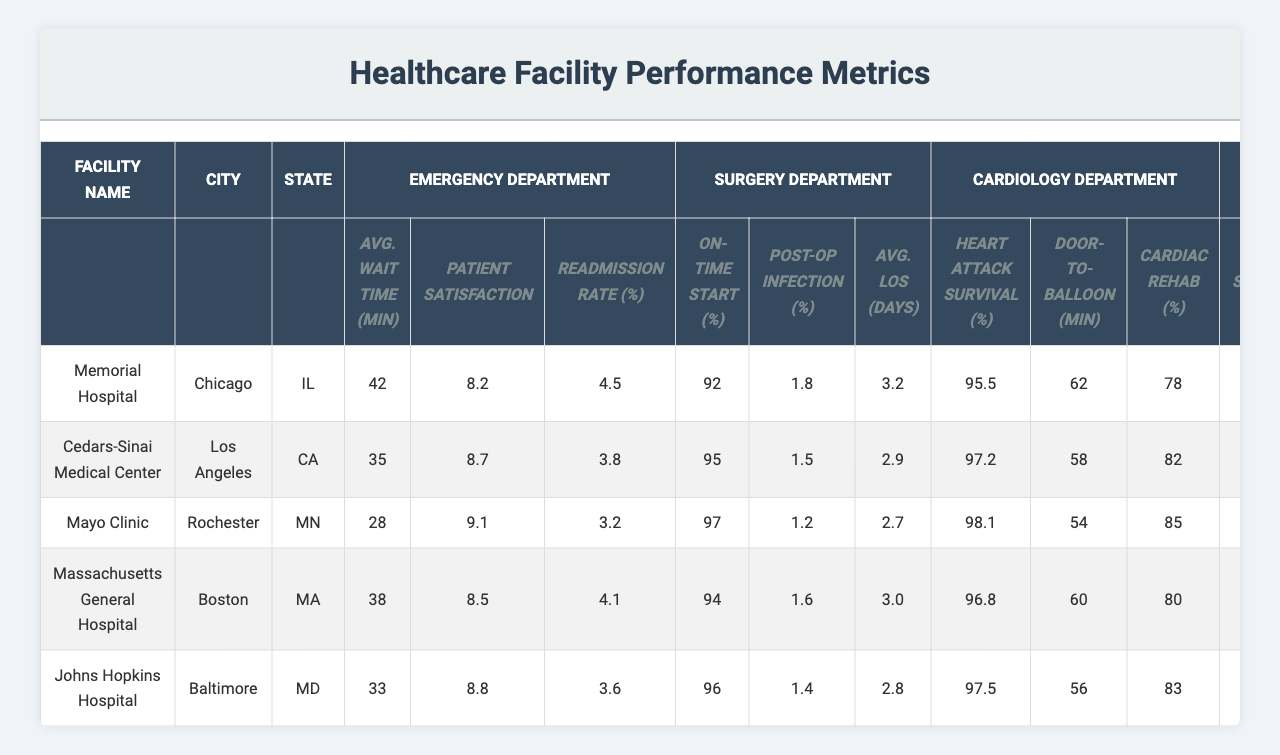What is the average wait time in the emergency department for Cedars-Sinai Medical Center? The table shows the average wait time for Cedars-Sinai Medical Center's emergency department as 35 minutes.
Answer: 35 minutes Which facility has the highest patient satisfaction score in the emergency department? By comparing the patient satisfaction scores from the table, Mayo Clinic has the highest score at 9.1.
Answer: Mayo Clinic What is the on-time start percentage for the surgery department at Memorial Hospital? The table indicates that Memorial Hospital has an on-time start percentage of 92% in its surgery department.
Answer: 92% Is the post-op infection rate at Mayo Clinic lower than that at Massachusetts General Hospital? The post-op infection rate for Mayo Clinic is 1.2% and for Massachusetts General Hospital is 1.6%. Since 1.2% is lower than 1.6%, the answer is yes.
Answer: Yes What is the average length of stay in days across all surgery departments listed? The average length of stay is calculated by taking the sum of the lengths (3.2 + 2.9 + 2.7 + 3.0 + 2.8) = 14.6 days, then dividing by 5 facilities gives 14.6/5 = 2.92 days.
Answer: 2.92 days Which facility has the lowest readmission rate in the emergency department? Looking at the readmission rates, Mayo Clinic has the lowest rate at 3.2%.
Answer: Mayo Clinic What is the average heart attack survival rate across the cardiology departments? The average survival rate is calculated as (95.5 + 97.2 + 98.1 + 96.8 + 97.5) = 485.1, then dividing by 5 gives 485.1/5 = 97.02%.
Answer: 97.02% Does Memorial Hospital have a higher five-year survival rate than Massachusetts General Hospital in oncology? The five-year survival rate for Memorial Hospital is 68% while for Massachusetts General Hospital it is 73%. Since 68% is not greater than 73%, the answer is no.
Answer: No What is the difference in clinical trial participation rate between Mayo Clinic and Johns Hopkins Hospital? Mayo Clinic has a clinical trial participation rate of 18% while Johns Hopkins Hospital has 17%. The difference is 18% - 17% = 1%.
Answer: 1% Which facility has the highest heart attack survival rate and what is that rate? Comparing the heart attack survival rates, Mayo Clinic has the highest at 98.1%.
Answer: Mayo Clinic, 98.1% 